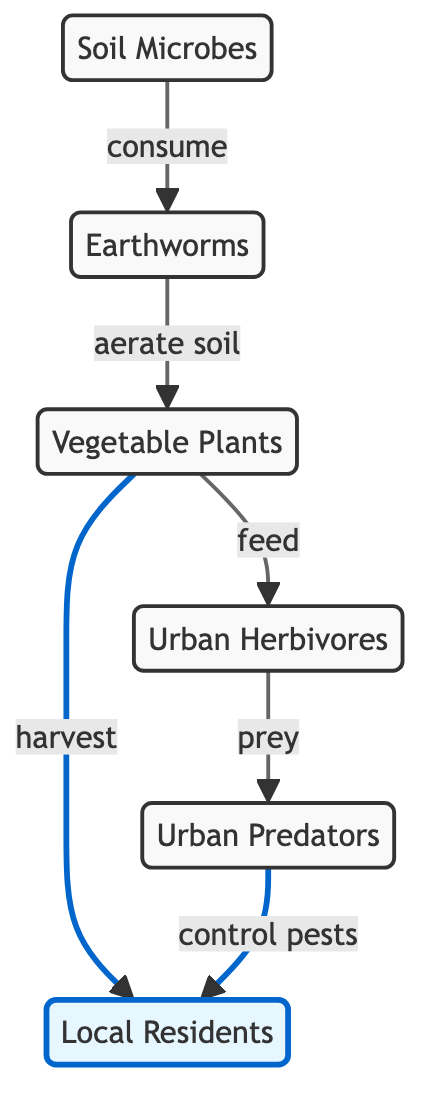What are the primary producers in this food web? The primary producers are the plants, as they convert sunlight into energy through photosynthesis and serve as a food source for herbivores.
Answer: Vegetable Plants How many predator types are shown in the diagram? The diagram shows one type of predator, labeled as Urban Predators, which is the only node that represents predators in this food web.
Answer: 1 Who benefits from soil aeration? The plants benefit from soil aeration because earthworms aerate the soil, which helps improve the growth conditions for the plants.
Answer: Vegetable Plants What do herbivores consume? Herbivores consume the plants, as indicated by the arrow pointing from plants to herbivores labeled "feed."
Answer: Vegetable Plants What role do humans play in relation to predators? Humans benefit from predators as they control pests, thereby contributing to a healthier urban garden for the residents.
Answer: control pests How many links are there between soil microbes and other organisms? There is one direct link between soil microbes and earthworms indicated by the arrow showing the consumption relationship.
Answer: 1 What type of residents are indicated as consumers in the food web? The diagram indicates local residents as consumers in the food web, clearly stating who benefits from harvesting plants.
Answer: Local Residents What type of interaction occurs between earthworms and plants? The interaction between earthworms and plants is that earthworms aerate the soil, which is beneficial for plant growth.
Answer: aerate soil Which organisms are at the top of the food chain in this diagram? The top organisms in this food chain are the urban predators, as they prey on the herbivores, indicating a predator-prey relationship.
Answer: Urban Predators 